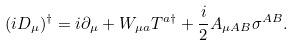Convert formula to latex. <formula><loc_0><loc_0><loc_500><loc_500>( i D _ { \mu } ) ^ { \dagger } = i \partial _ { \mu } + W _ { \mu a } T ^ { a \dagger } + \frac { i } { 2 } A _ { \mu A B } \sigma ^ { A B } .</formula> 